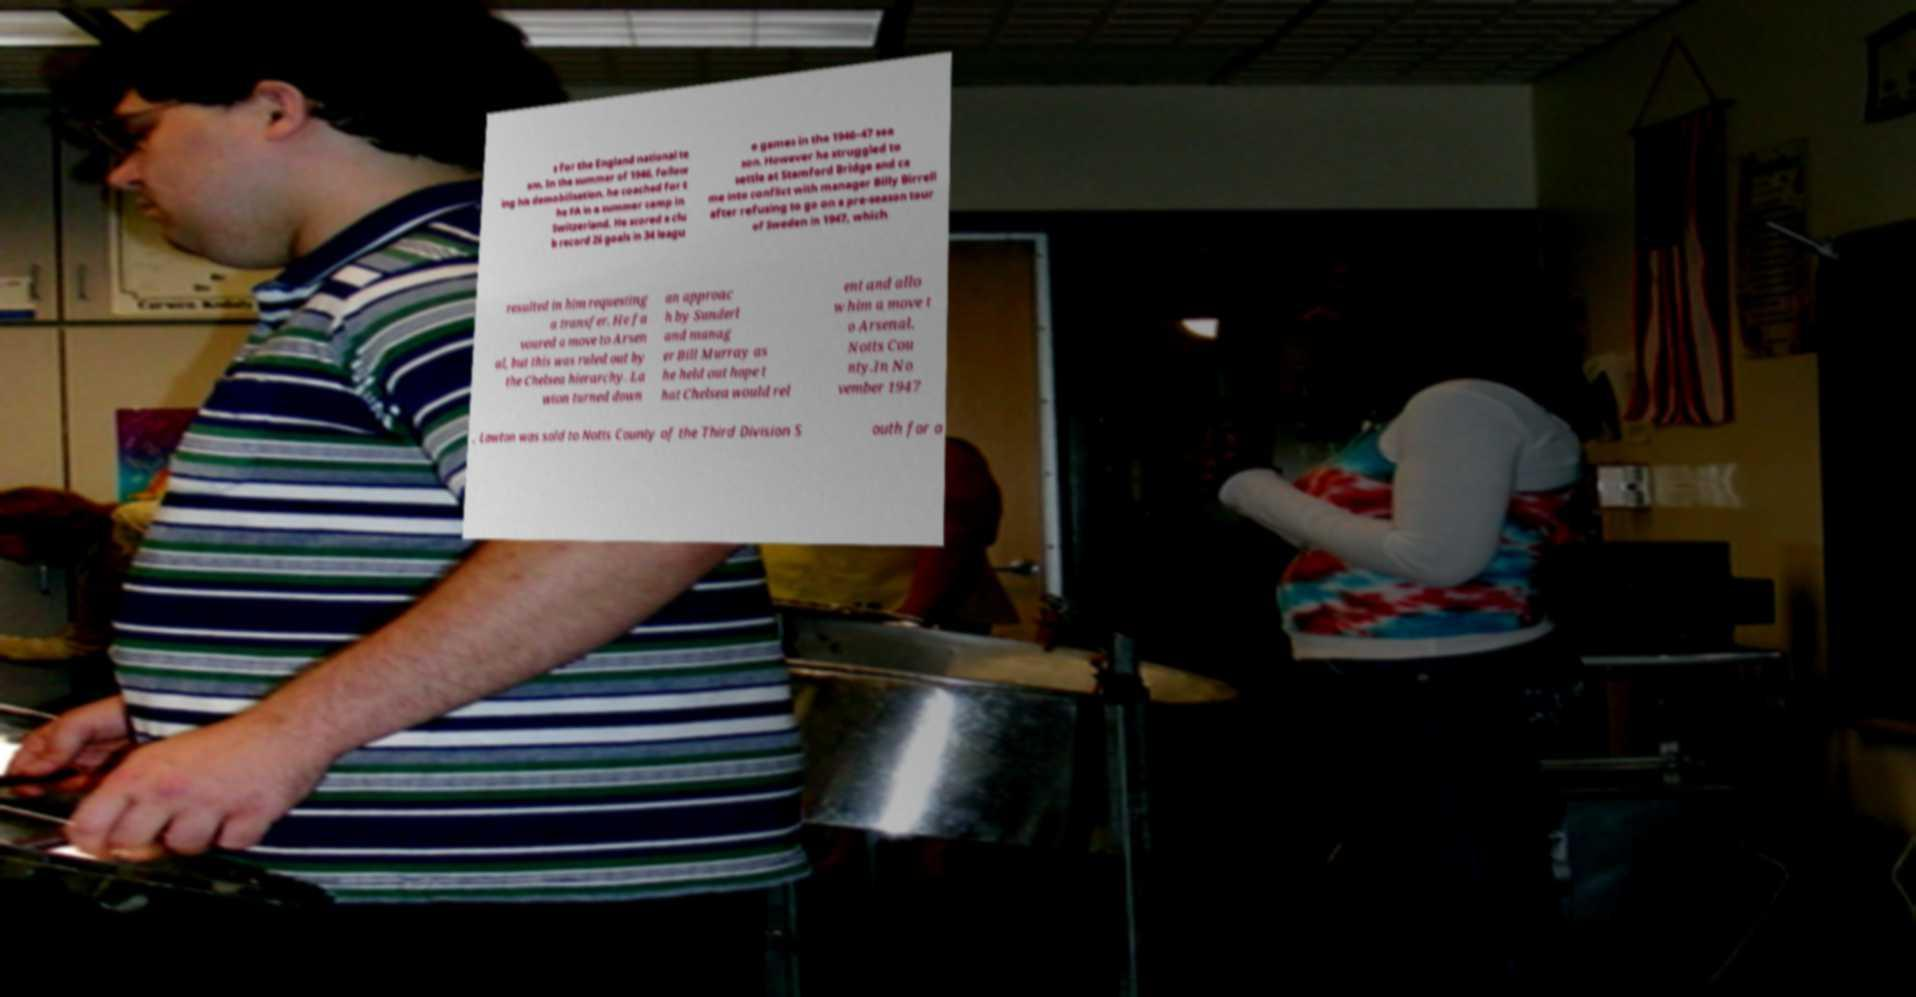Please read and relay the text visible in this image. What does it say? s for the England national te am. In the summer of 1946, follow ing his demobilisation, he coached for t he FA in a summer camp in Switzerland. He scored a clu b record 26 goals in 34 leagu e games in the 1946–47 sea son. However he struggled to settle at Stamford Bridge and ca me into conflict with manager Billy Birrell after refusing to go on a pre-season tour of Sweden in 1947, which resulted in him requesting a transfer. He fa voured a move to Arsen al, but this was ruled out by the Chelsea hierarchy. La wton turned down an approac h by Sunderl and manag er Bill Murray as he held out hope t hat Chelsea would rel ent and allo w him a move t o Arsenal. Notts Cou nty.In No vember 1947 , Lawton was sold to Notts County of the Third Division S outh for a 